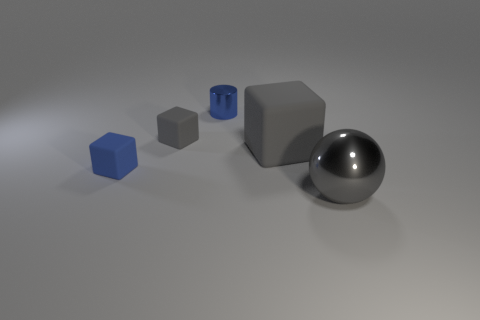Is there any other thing that has the same shape as the big gray metal object?
Offer a very short reply. No. What material is the gray object on the left side of the tiny metallic cylinder?
Give a very brief answer. Rubber. Are there any tiny rubber things right of the small blue cylinder?
Provide a succinct answer. No. There is a gray metal object; what shape is it?
Keep it short and to the point. Sphere. How many things are objects that are right of the blue metal cylinder or tiny purple rubber cylinders?
Keep it short and to the point. 2. What number of other objects are there of the same color as the large rubber block?
Your answer should be very brief. 2. There is a big rubber thing; is its color the same as the shiny thing behind the gray metal object?
Provide a short and direct response. No. What is the color of the other tiny thing that is the same shape as the small gray object?
Make the answer very short. Blue. Is the material of the tiny gray thing the same as the big object that is behind the large metal object?
Offer a terse response. Yes. The small metal thing has what color?
Give a very brief answer. Blue. 